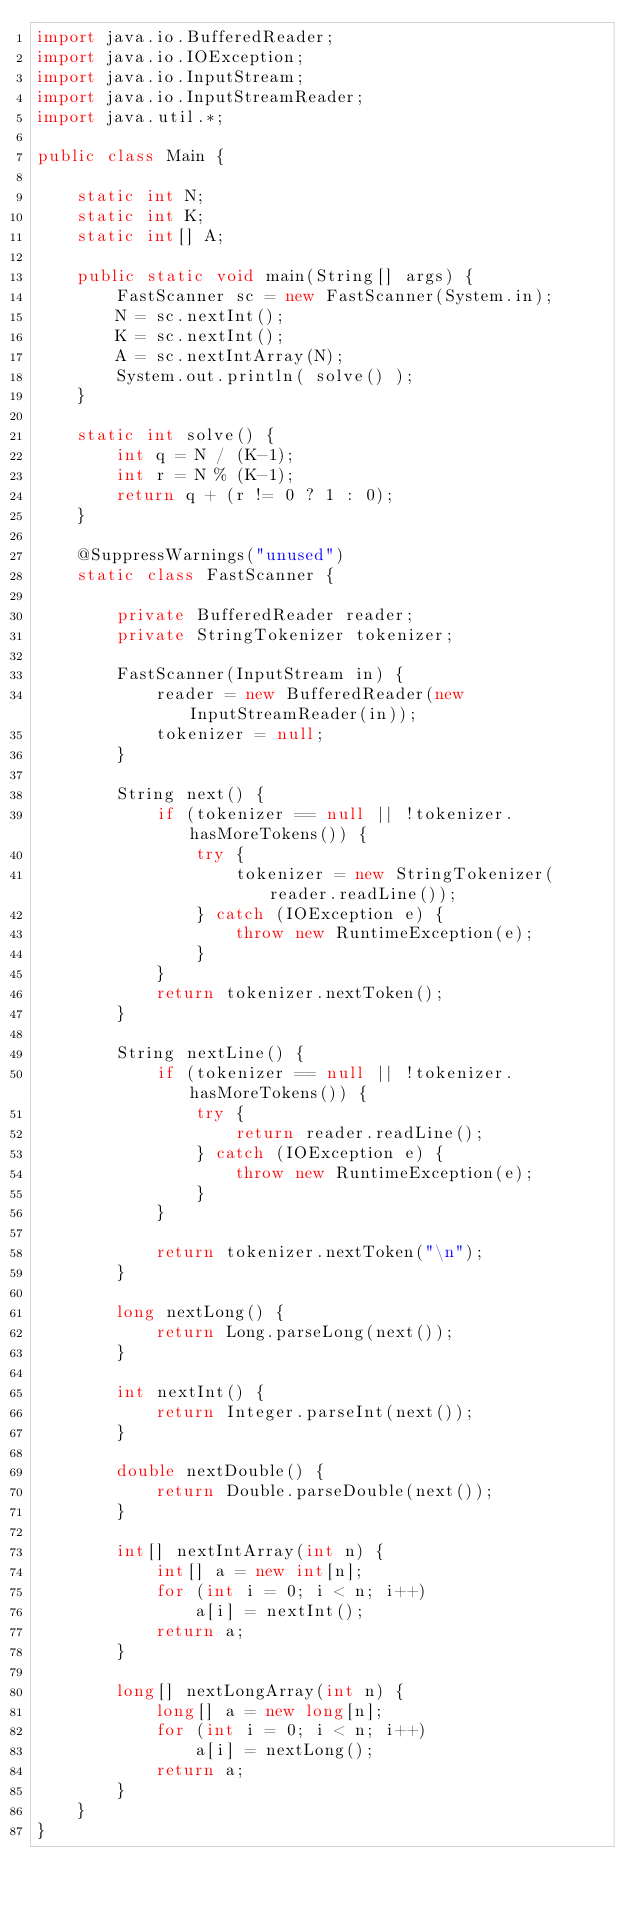<code> <loc_0><loc_0><loc_500><loc_500><_Java_>import java.io.BufferedReader;
import java.io.IOException;
import java.io.InputStream;
import java.io.InputStreamReader;
import java.util.*;

public class Main {

    static int N;
    static int K;
    static int[] A;

    public static void main(String[] args) {
        FastScanner sc = new FastScanner(System.in);
        N = sc.nextInt();
        K = sc.nextInt();
        A = sc.nextIntArray(N);
        System.out.println( solve() );
    }

    static int solve() {
        int q = N / (K-1);
        int r = N % (K-1);
        return q + (r != 0 ? 1 : 0);
    }

    @SuppressWarnings("unused")
    static class FastScanner {

        private BufferedReader reader;
        private StringTokenizer tokenizer;

        FastScanner(InputStream in) {
            reader = new BufferedReader(new InputStreamReader(in));
            tokenizer = null;
        }

        String next() {
            if (tokenizer == null || !tokenizer.hasMoreTokens()) {
                try {
                    tokenizer = new StringTokenizer(reader.readLine());
                } catch (IOException e) {
                    throw new RuntimeException(e);
                }
            }
            return tokenizer.nextToken();
        }

        String nextLine() {
            if (tokenizer == null || !tokenizer.hasMoreTokens()) {
                try {
                    return reader.readLine();
                } catch (IOException e) {
                    throw new RuntimeException(e);
                }
            }

            return tokenizer.nextToken("\n");
        }

        long nextLong() {
            return Long.parseLong(next());
        }

        int nextInt() {
            return Integer.parseInt(next());
        }

        double nextDouble() {
            return Double.parseDouble(next());
        }

        int[] nextIntArray(int n) {
            int[] a = new int[n];
            for (int i = 0; i < n; i++)
                a[i] = nextInt();
            return a;
        }

        long[] nextLongArray(int n) {
            long[] a = new long[n];
            for (int i = 0; i < n; i++)
                a[i] = nextLong();
            return a;
        }
    }
}

</code> 